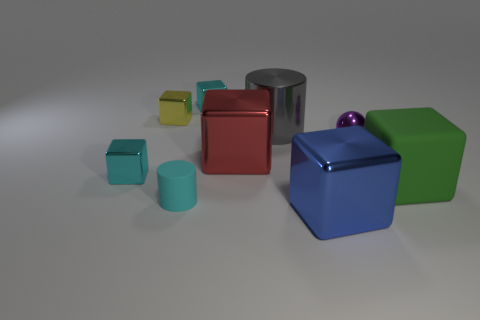Can you describe the lighting in the scene? The lighting in the scene is soft and diffused, creating gentle shadows on the ground. The light source seems to be positioned above and slightly in front of the objects, casting subtle highlights on the metallic surfaces and giving the scene a calm, studio-like ambiance. 